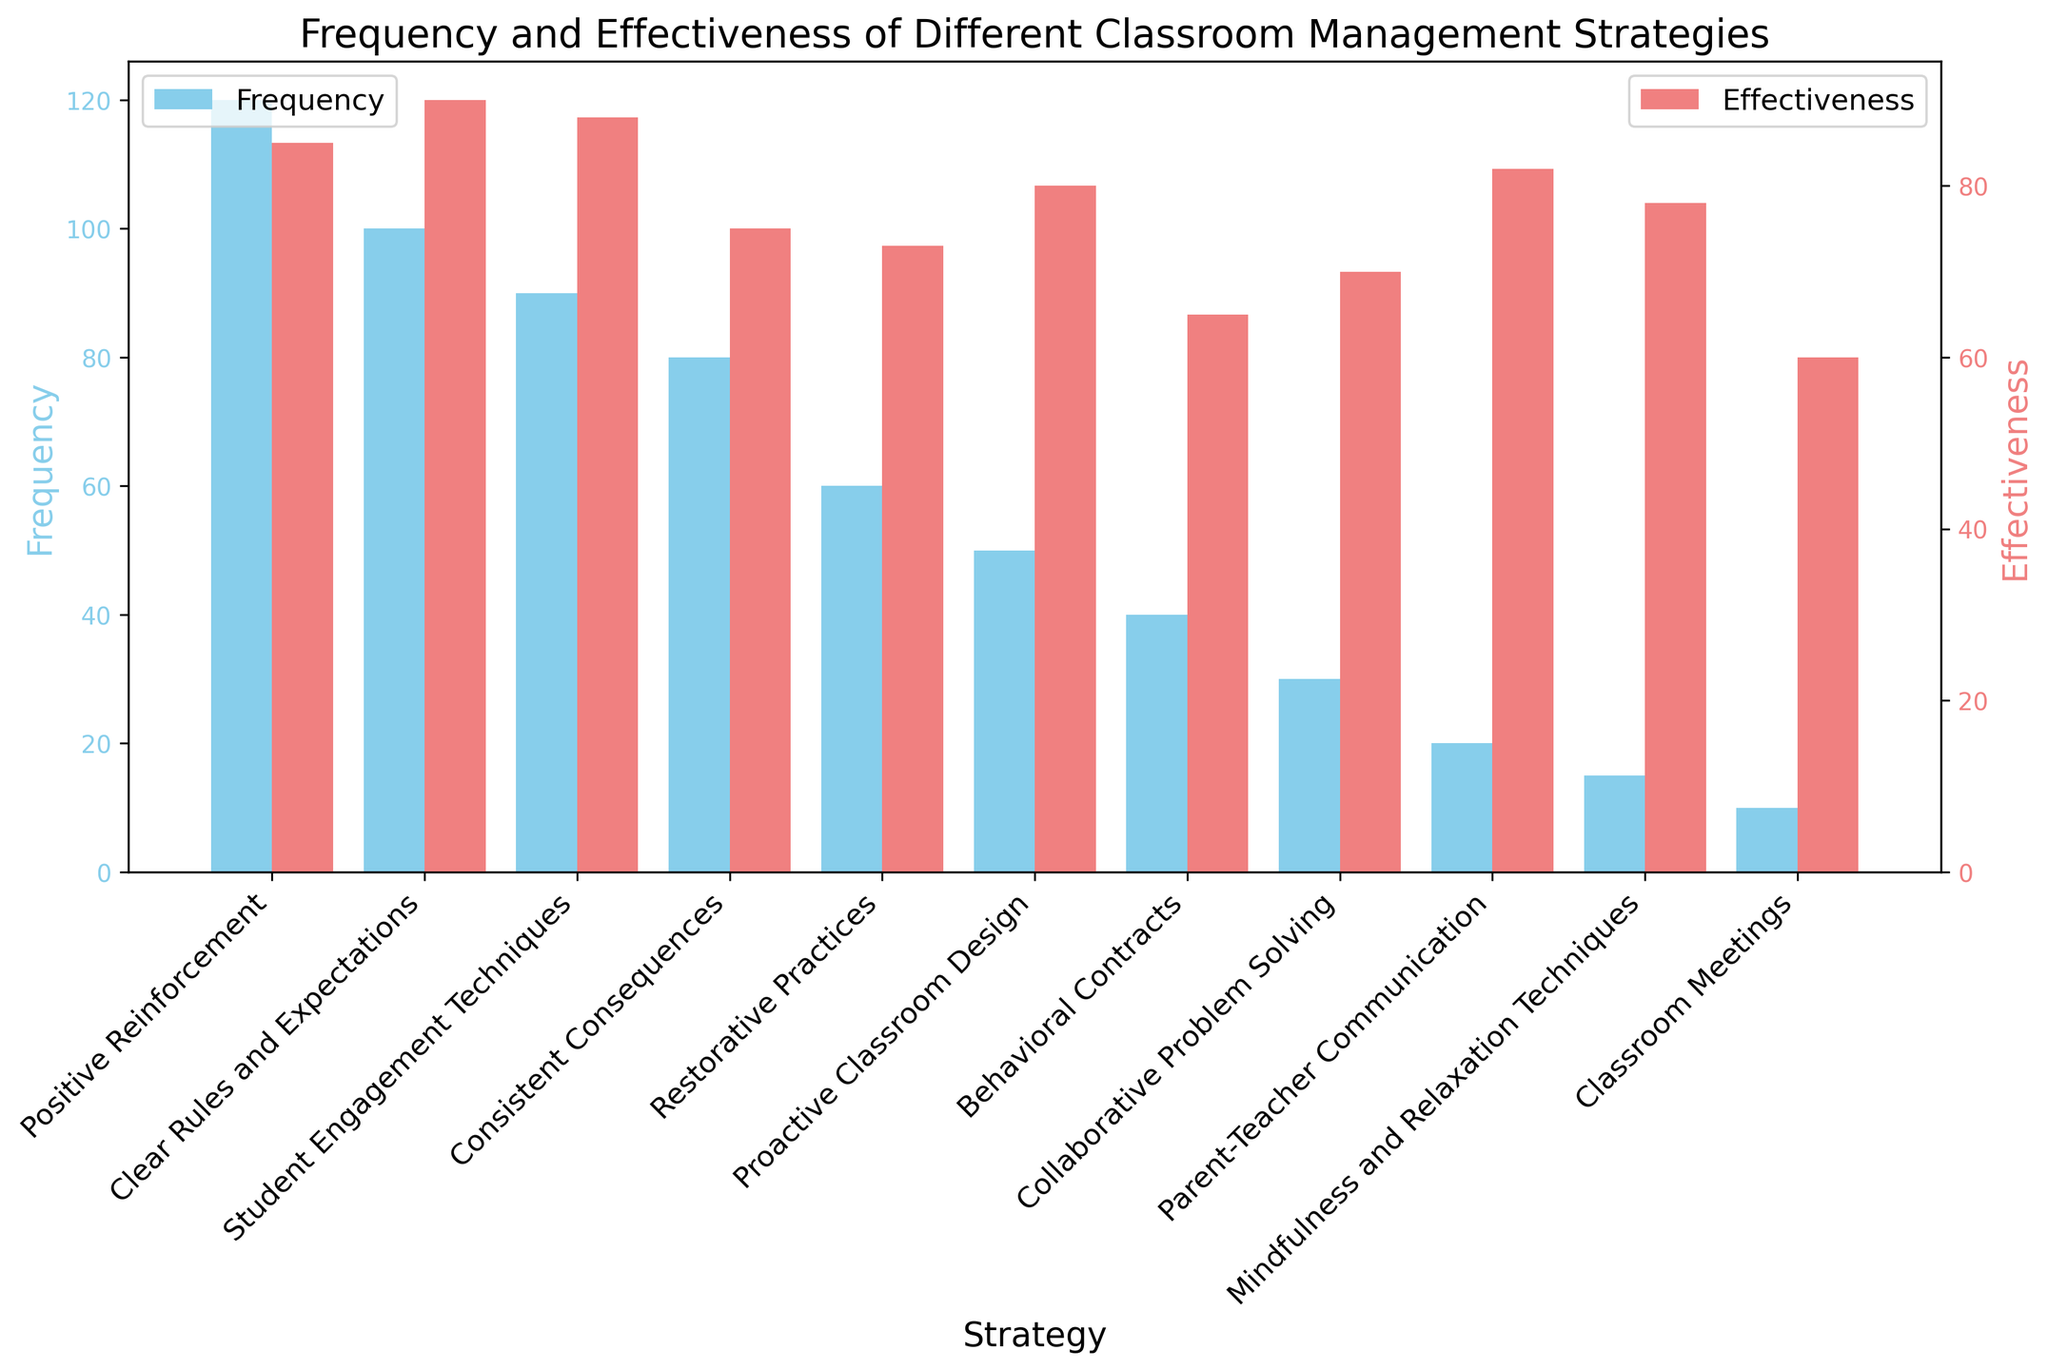What is the most frequently used classroom management strategy? The bar representing "Positive Reinforcement" is the tallest among all the frequency bars. Therefore, "Positive Reinforcement" is the most frequently used strategy.
Answer: Positive Reinforcement Which strategy shows the highest reported effectiveness? The bar representing "Clear Rules and Expectations" is the tallest among all the effectiveness bars. Therefore, "Clear Rules and Expectations" has the highest reported effectiveness.
Answer: Clear Rules and Expectations Which strategy has a frequency lower than "Student Engagement Techniques"? "Student Engagement Techniques" has a frequency of 90. The strategies with lower frequency include "Consistent Consequences," "Restorative Practices," "Proactive Classroom Design," "Behavioral Contracts," "Collaborative Problem Solving," "Parent-Teacher Communication," "Mindfulness and Relaxation Techniques," and "Classroom Meetings."
Answer: Consistent Consequences, Restorative Practices, Proactive Classroom Design, Behavioral Contracts, Collaborative Problem Solving, Parent-Teacher Communication, Mindfulness and Relaxation Techniques, Classroom Meetings How does the effectiveness of "Parent-Teacher Communication" compare to "Behavioral Contracts"? The effectiveness of "Parent-Teacher Communication" is 82, while the effectiveness of "Behavioral Contracts" is 65. Parent-Teacher Communication has a higher effectiveness compared to Behavioral Contracts.
Answer: Parent-Teacher Communication is higher What is the difference in effectiveness between "Restorative Practices" and "Mindfulness and Relaxation Techniques"? The reported effectiveness of "Restorative Practices" is 73, and for "Mindfulness and Relaxation Techniques," it is 78. The difference is 78 - 73 = 5.
Answer: 5 Which classroom management strategy has the lowest reported effectiveness? The bar representing "Classroom Meetings" is the shortest among all the effectiveness bars. Therefore, "Classroom Meetings" has the lowest reported effectiveness.
Answer: Classroom Meetings What is the combined frequency of "Proactive Classroom Design" and "Behavioral Contracts"? The frequency for "Proactive Classroom Design" is 50, and for "Behavioral Contracts," it is 40. The combined frequency is 50 + 40 = 90.
Answer: 90 Are there any strategies that have both frequency and effectiveness levels above 80? If yes, which ones? By examining both axes, "Positive Reinforcement," "Clear Rules and Expectations," and "Student Engagement Techniques" have effectiveness and frequency levels above 80.
Answer: Positive Reinforcement, Clear Rules and Expectations, Student Engagement Techniques What is the effectiveness value of the strategy with the highest frequency? "Positive Reinforcement" has the highest frequency of 120. Its effectiveness value is 85, as depicted by the corresponding bar on the twin axis.
Answer: 85 